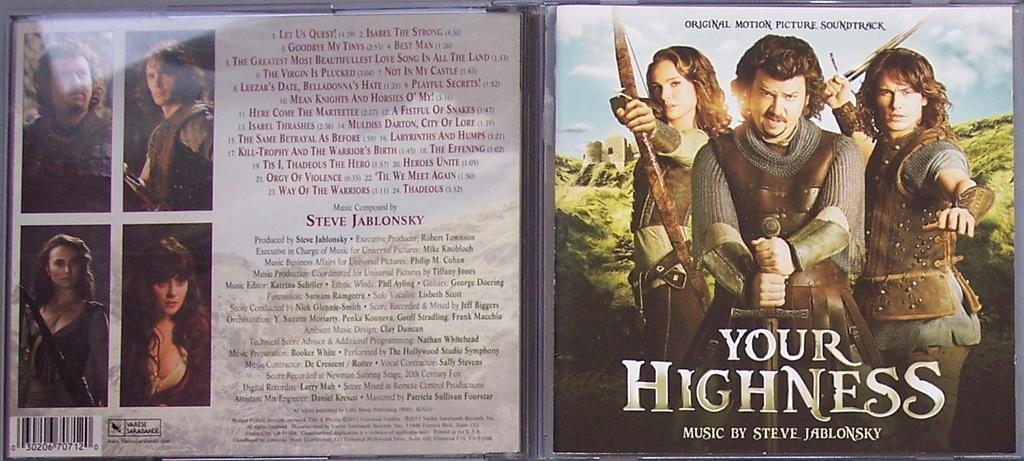<image>
Offer a succinct explanation of the picture presented. An open CD case for the movie Your Highness. 